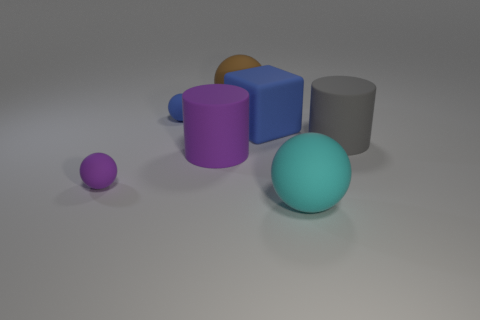Subtract all blue balls. How many balls are left? 3 Subtract all blocks. How many objects are left? 6 Add 3 big rubber objects. How many objects exist? 10 Subtract all blue spheres. How many spheres are left? 3 Add 5 large yellow cylinders. How many large yellow cylinders exist? 5 Subtract 0 yellow cubes. How many objects are left? 7 Subtract 1 balls. How many balls are left? 3 Subtract all gray balls. Subtract all cyan cubes. How many balls are left? 4 Subtract all gray blocks. How many purple cylinders are left? 1 Subtract all gray objects. Subtract all blue objects. How many objects are left? 4 